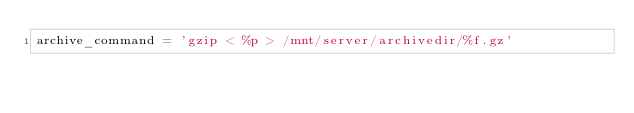<code> <loc_0><loc_0><loc_500><loc_500><_SQL_>archive_command = 'gzip < %p > /mnt/server/archivedir/%f.gz'
</code> 